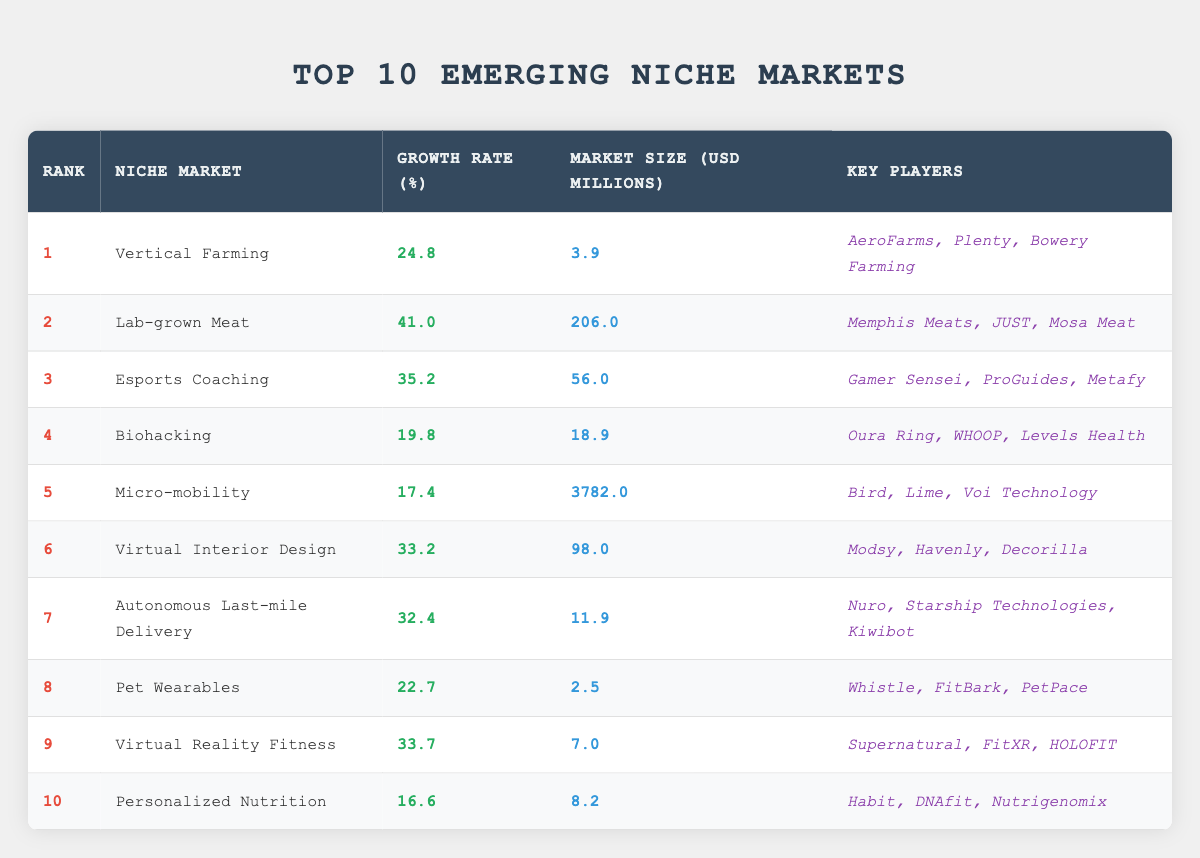What is the highest growth rate among the emerging niche markets? Looking at the table, the niche market with the highest growth rate is "Lab-grown Meat," which has a growth rate of 41.0%.
Answer: 41.0% Which niche market has the largest market size? Based on the market size values in the table, "Micro-mobility" is the largest with a market size of 3782.0 million USD.
Answer: 3782.0 million USD Is "Vertical Farming" one of the top three niche markets by growth rate? Checking the growth rates of the top three markets, the highest are "Lab-grown Meat," "Esports Coaching," and "Virtual Reality Fitness," so "Vertical Farming" is not in the top three.
Answer: No What is the average growth rate of the top five niche markets? To find the average, sum the growth rates of the top five markets (41.0 + 35.2 + 33.7 + 32.4 + 24.8 = 206.1) and divide by 5. The average growth rate is 206.1 / 5 = 41.22%.
Answer: 41.22% Which key player is associated with "Biohacking"? Referring to the table, the key players listed for "Biohacking" are "Oura Ring, WHOOP, Levels Health." Therefore, any of these three can be mentioned as associated key players.
Answer: Oura Ring, WHOOP, Levels Health How many niche markets have a growth rate higher than 30%? By examining the growth rates, we can see that "Lab-grown Meat," "Esports Coaching," "Virtual Interior Design," "Autonomous Last-mile Delivery," and "Virtual Reality Fitness" are the markets with growth rates higher than 30%, totaling 5 markets.
Answer: 5 Is "Pet Wearables" ranked higher than "Personalized Nutrition"? Looking at the rankings, "Pet Wearables" is ranked 8th while "Personalized Nutrition" is ranked 10th, meaning "Pet Wearables" is indeed ranked higher.
Answer: Yes What is the total market size of all ten emerging niche markets? To find the total market size, we sum the market sizes: (3.9 + 206.0 + 56.0 + 18.9 + 3782.0 + 98.0 + 11.9 + 2.5 + 7.0 + 8.2 = 4142.4). The total market size across all ten is 4142.4 million USD.
Answer: 4142.4 million USD 